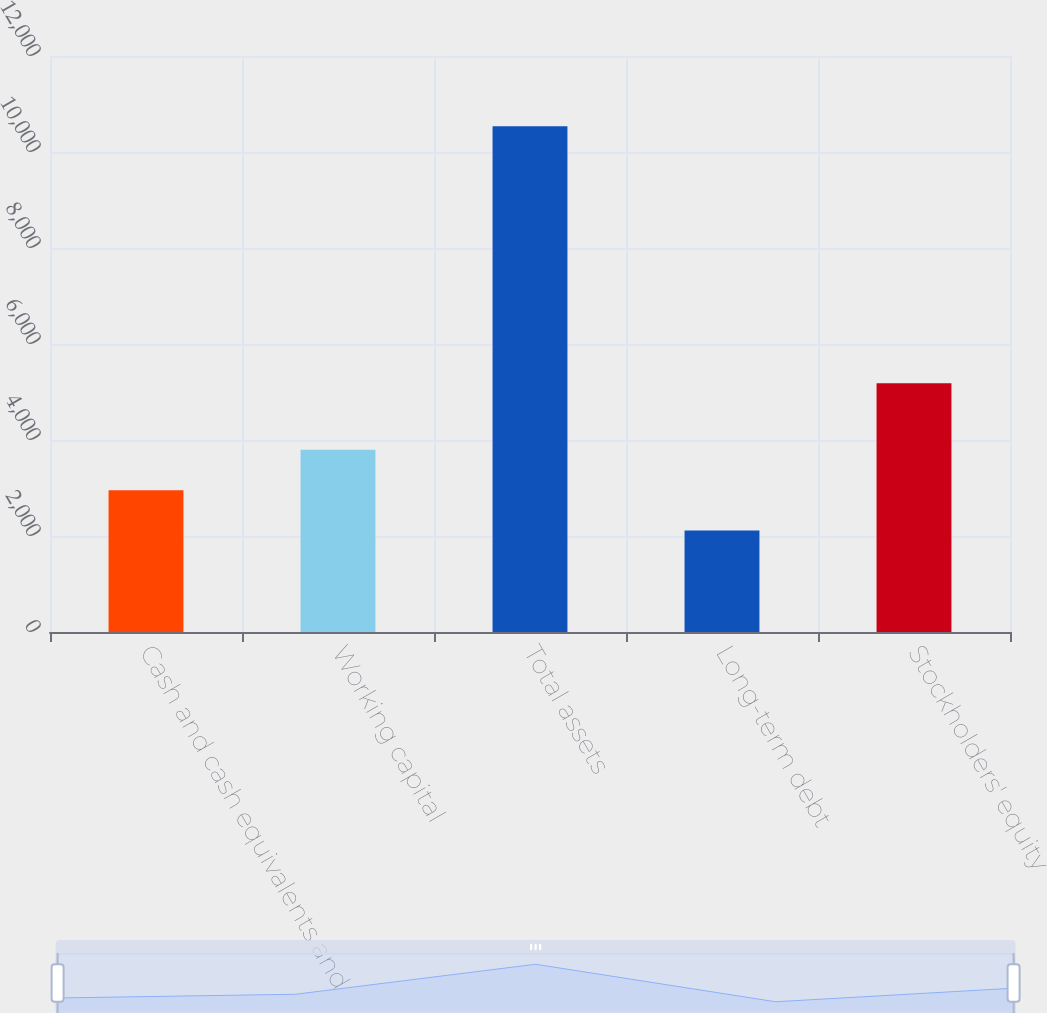Convert chart to OTSL. <chart><loc_0><loc_0><loc_500><loc_500><bar_chart><fcel>Cash and cash equivalents and<fcel>Working capital<fcel>Total assets<fcel>Long-term debt<fcel>Stockholders' equity<nl><fcel>2954.4<fcel>3796.8<fcel>10536<fcel>2112<fcel>5182<nl></chart> 